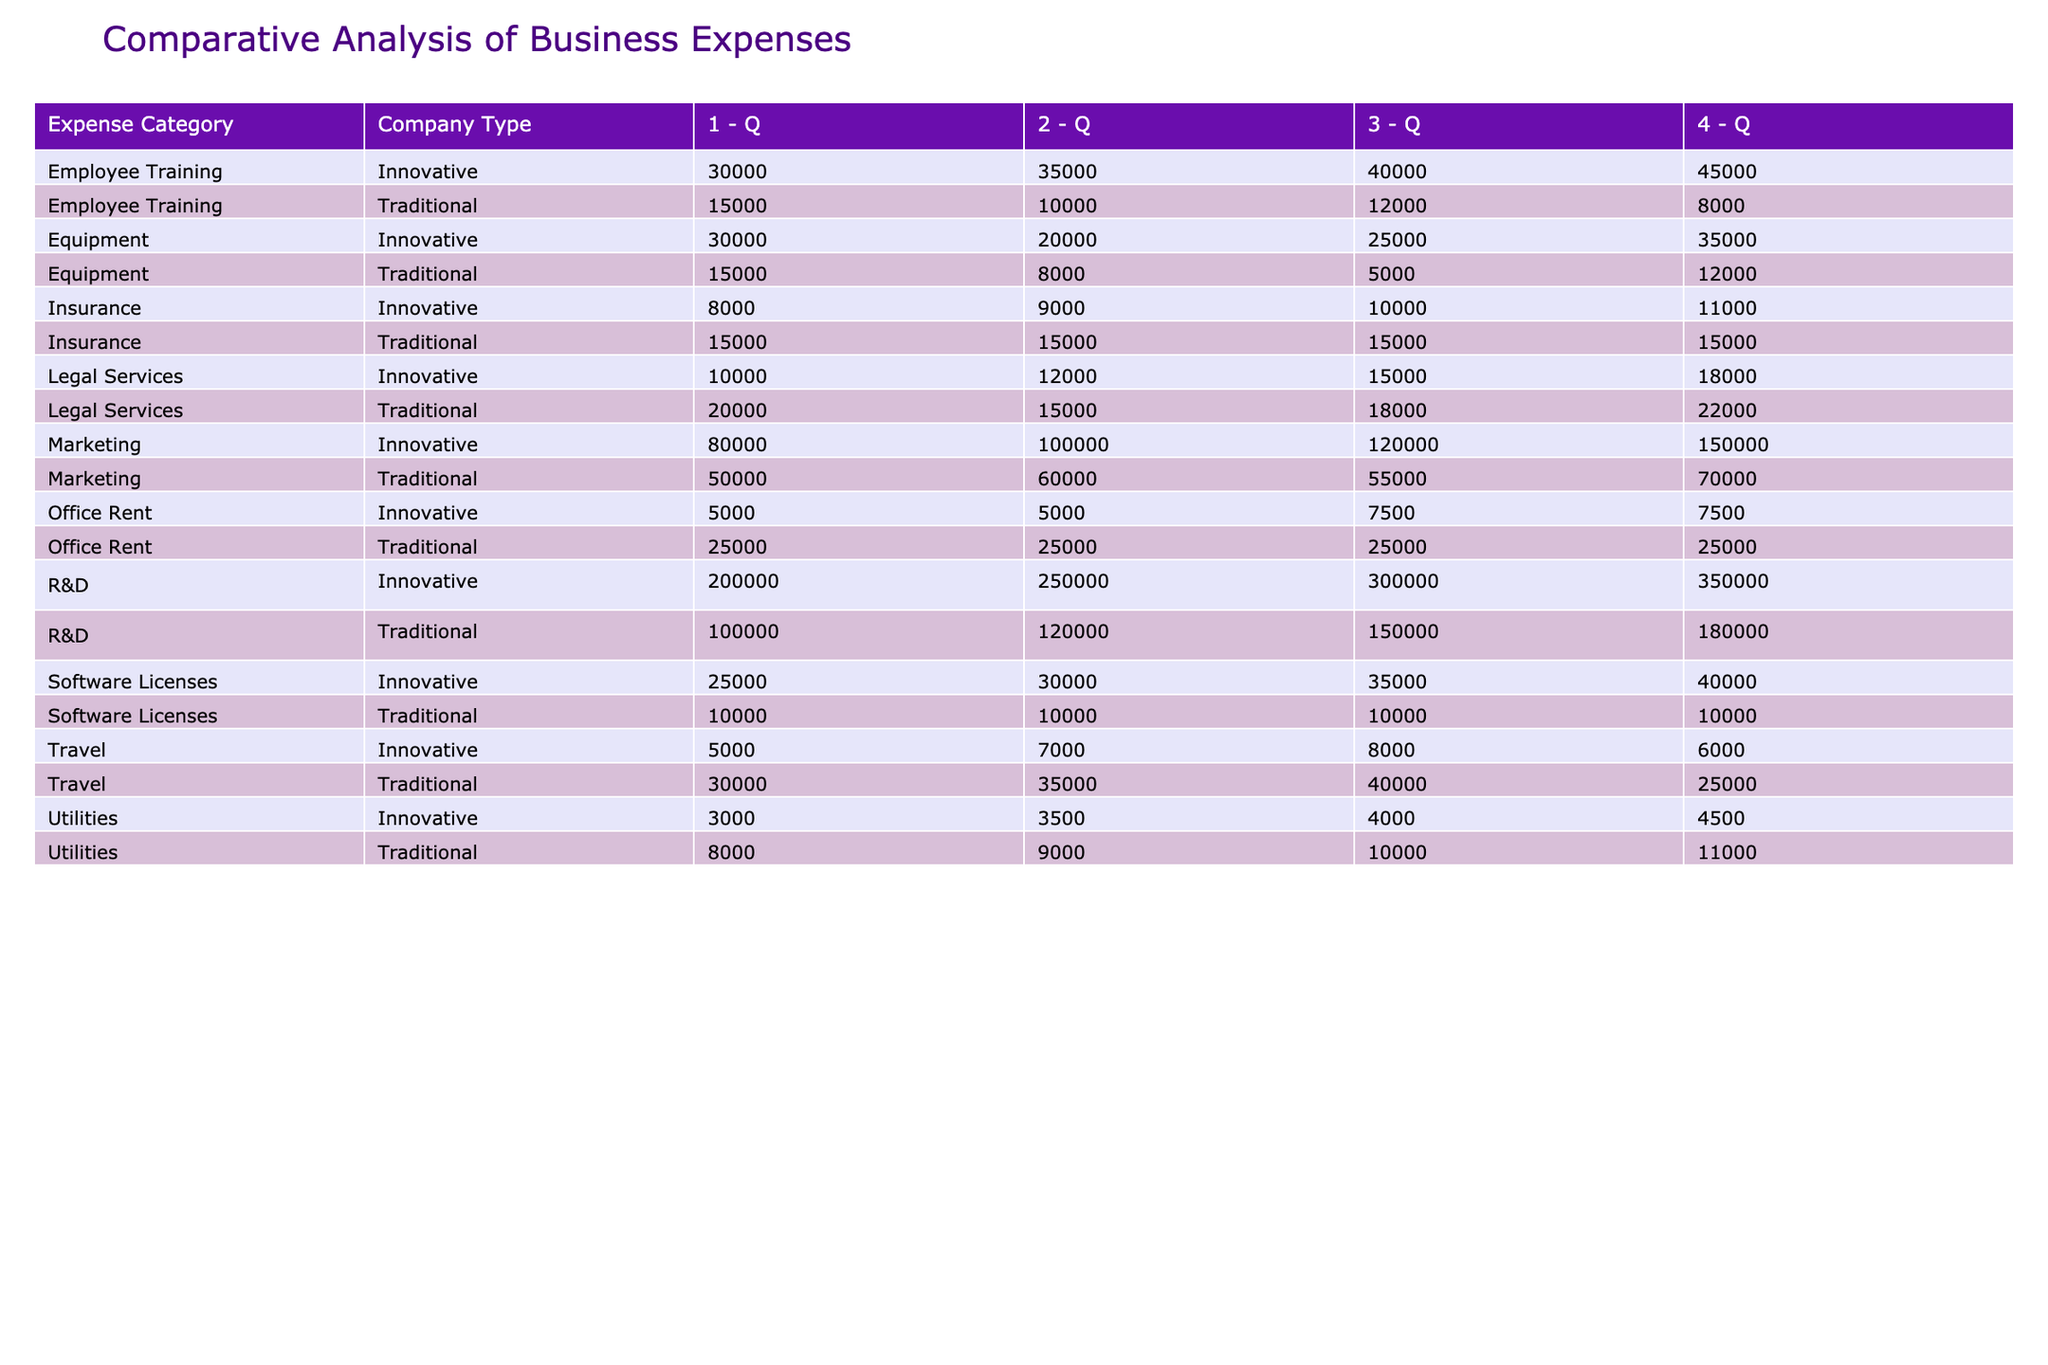What is the total marketing expense for innovative startups in Q3 2023? The marketing expenses for innovative startups in Q3 2023 can be found under the "Marketing" category for "Innovative" in the table. This value is 120,000.
Answer: 120000 Which type of companies spent more on office rent in Q4 2023? In Q4 2023, traditional companies spent 25,000 on office rent while innovative companies spent 7,500. Hence, traditional companies had a higher expense.
Answer: Traditional What is the difference in total employee training expenses between traditional and innovative startups for all quarters? The total employee training expense for traditional startups is (15,000 + 10,000 + 12,000 + 8,000) = 45,000, and for innovative startups, it is (30,000 + 35,000 + 40,000 + 45,000) = 150,000. The difference is 150,000 - 45,000 = 105,000.
Answer: 105000 Did innovative startups spend less on utilities compared to traditional startups in Q1 2023? The table shows that traditional startups spent 8,000 on utilities whereas innovative startups spent 3,000 in Q1 2023. This confirms that innovative startups spent less.
Answer: Yes What is the average annual expense on R&D for traditional startups? The R&D expenses for traditional startups for each quarter are 100,000, 120,000, 150,000, and 180,000. To find the average, sum these values: 100,000 + 120,000 + 150,000 + 180,000 = 550,000. Then divide by 4, resulting in an average of 137,500.
Answer: 137500 What was the highest quarterly expense category for innovative startups, and in which quarter did it occur? Looking through the expenses, marketing for innovative startups is the highest in Q4 2023 with 150,000. None of the other categories exceed this amount.
Answer: Marketing, Q4 2023 What are the total expenses for equipment for traditional companies across all quarters? The equipment expenses for traditional companies are 15,000, 8,000, 5,000, and 12,000 across the quarters. Adding these amounts leads to a total of 40,000.
Answer: 40000 Which company type had higher total legal services expenses across all quarters? The legal services expenses for traditional companies total (20,000 + 15,000 + 18,000 + 22,000) = 75,000, while innovative companies spent (10,000 + 12,000 + 15,000 + 18,000) = 55,000. Therefore, traditional companies spent more.
Answer: Traditional What is the sum of travel expenses for all traditional startups from Q1 to Q4 2023? Summing the travel expenses for traditional startups gives (30,000 + 35,000 + 40,000 + 25,000) = 130,000 for Q1 to Q4 2023.
Answer: 130000 